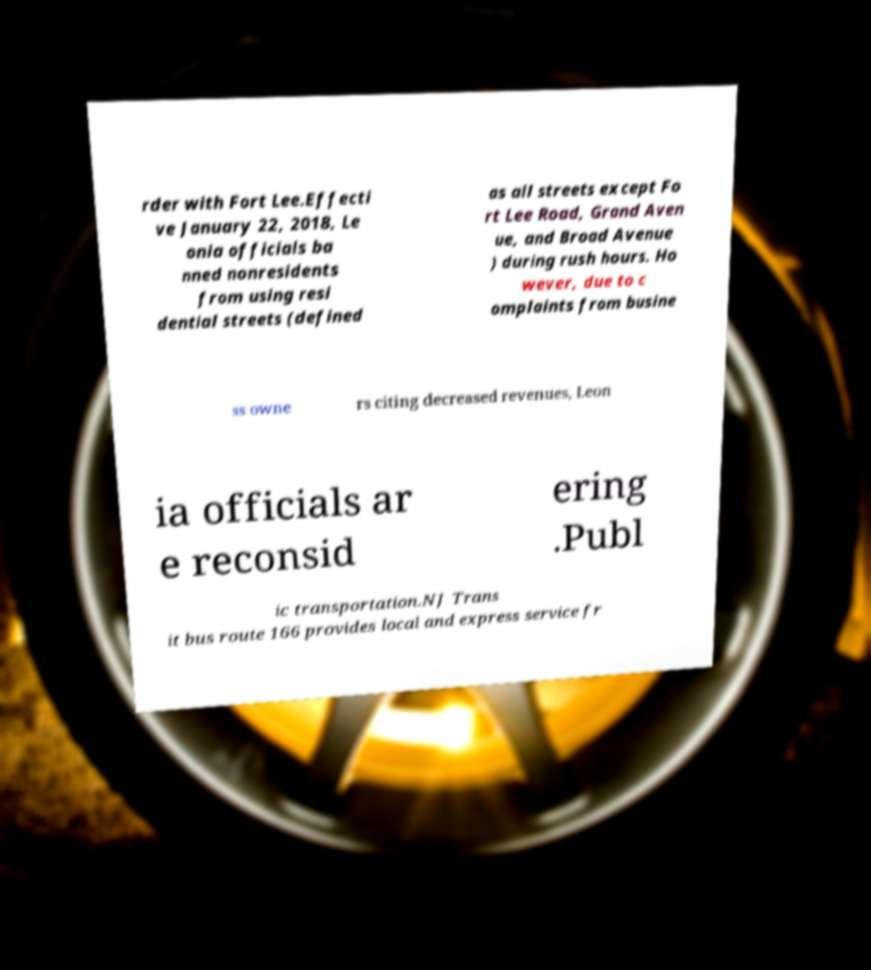Please read and relay the text visible in this image. What does it say? rder with Fort Lee.Effecti ve January 22, 2018, Le onia officials ba nned nonresidents from using resi dential streets (defined as all streets except Fo rt Lee Road, Grand Aven ue, and Broad Avenue ) during rush hours. Ho wever, due to c omplaints from busine ss owne rs citing decreased revenues, Leon ia officials ar e reconsid ering .Publ ic transportation.NJ Trans it bus route 166 provides local and express service fr 